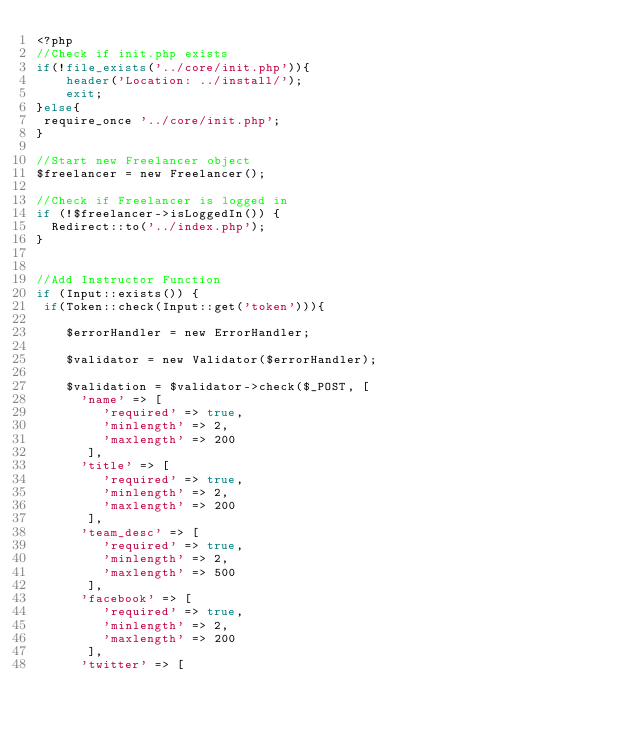<code> <loc_0><loc_0><loc_500><loc_500><_PHP_><?php 
//Check if init.php exists
if(!file_exists('../core/init.php')){
	header('Location: ../install/');        
    exit;
}else{
 require_once '../core/init.php';	
}

//Start new Freelancer object
$freelancer = new Freelancer();

//Check if Freelancer is logged in
if (!$freelancer->isLoggedIn()) {
  Redirect::to('../index.php');	
}


//Add Instructor Function
if (Input::exists()) {
 if(Token::check(Input::get('token'))){
 	
	$errorHandler = new ErrorHandler;
	
	$validator = new Validator($errorHandler);
	
	$validation = $validator->check($_POST, [
	  'name' => [
		 'required' => true,
		 'minlength' => 2,
		 'maxlength' => 200
	   ],
	  'title' => [
		 'required' => true,
		 'minlength' => 2,
		 'maxlength' => 200
	   ],
	  'team_desc' => [
		 'required' => true,
		 'minlength' => 2,
		 'maxlength' => 500
	   ],
	  'facebook' => [
		 'required' => true,
		 'minlength' => 2,
		 'maxlength' => 200
	   ],
	  'twitter' => [</code> 